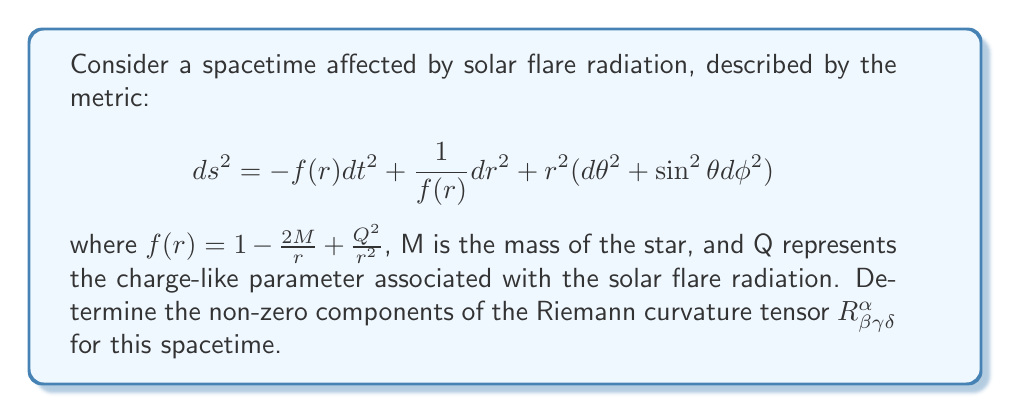What is the answer to this math problem? To determine the Riemann curvature tensor, we'll follow these steps:

1) First, we need to calculate the Christoffel symbols $\Gamma^\alpha_{\beta\gamma}$. The non-zero components are:

   $$\Gamma^t_{tr} = \Gamma^t_{rt} = \frac{f'}{2f}$$
   $$\Gamma^r_{tt} = \frac{ff'}{2}$$
   $$\Gamma^r_{rr} = -\frac{f'}{2f}$$
   $$\Gamma^r_{\theta\theta} = -rf$$
   $$\Gamma^r_{\phi\phi} = -rf\sin^2\theta$$
   $$\Gamma^\theta_{r\theta} = \Gamma^\theta_{\theta r} = \frac{1}{r}$$
   $$\Gamma^\theta_{\phi\phi} = -\sin\theta\cos\theta$$
   $$\Gamma^\phi_{r\phi} = \Gamma^\phi_{\phi r} = \frac{1}{r}$$
   $$\Gamma^\phi_{\theta\phi} = \Gamma^\phi_{\phi\theta} = \cot\theta$$

   where $f' = \frac{df}{dr} = \frac{2M}{r^2} - \frac{2Q^2}{r^3}$

2) Now, we can calculate the Riemann tensor using the formula:

   $$R^\alpha_{\beta\gamma\delta} = \partial_\gamma \Gamma^\alpha_{\beta\delta} - \partial_\delta \Gamma^\alpha_{\beta\gamma} + \Gamma^\alpha_{\lambda\gamma}\Gamma^\lambda_{\beta\delta} - \Gamma^\alpha_{\lambda\delta}\Gamma^\lambda_{\beta\gamma}$$

3) After calculations, the non-zero components are:

   $$R^t_{rtr} = -R^t_{rrt} = \frac{f''}{2f}$$
   $$R^r_{trt} = -R^r_{ttr} = -\frac{f''}{2}$$
   $$R^r_{\theta r \theta} = -R^r_{\theta \theta r} = R^\theta_{r \theta r} = -R^\theta_{\theta r r} = \frac{f'}{2r}$$
   $$R^r_{\phi r \phi} = -R^r_{\phi \phi r} = R^\phi_{r \phi r} = -R^\phi_{\phi r r} = \frac{f'\sin^2\theta}{2r}$$
   $$R^\theta_{\phi \theta \phi} = -R^\theta_{\phi \phi \theta} = R^\phi_{\theta \phi \theta} = -R^\phi_{\theta \theta \phi} = (1-f)\sin^2\theta$$

   where $f'' = \frac{d^2f}{dr^2} = -\frac{4M}{r^3} + \frac{6Q^2}{r^4}$

4) All other components can be derived from these using the symmetries of the Riemann tensor.
Answer: Non-zero components: $R^t_{rtr}, R^r_{trt}, R^r_{\theta r \theta}, R^r_{\phi r \phi}, R^\theta_{\phi \theta \phi}$ and their symmetric counterparts. 